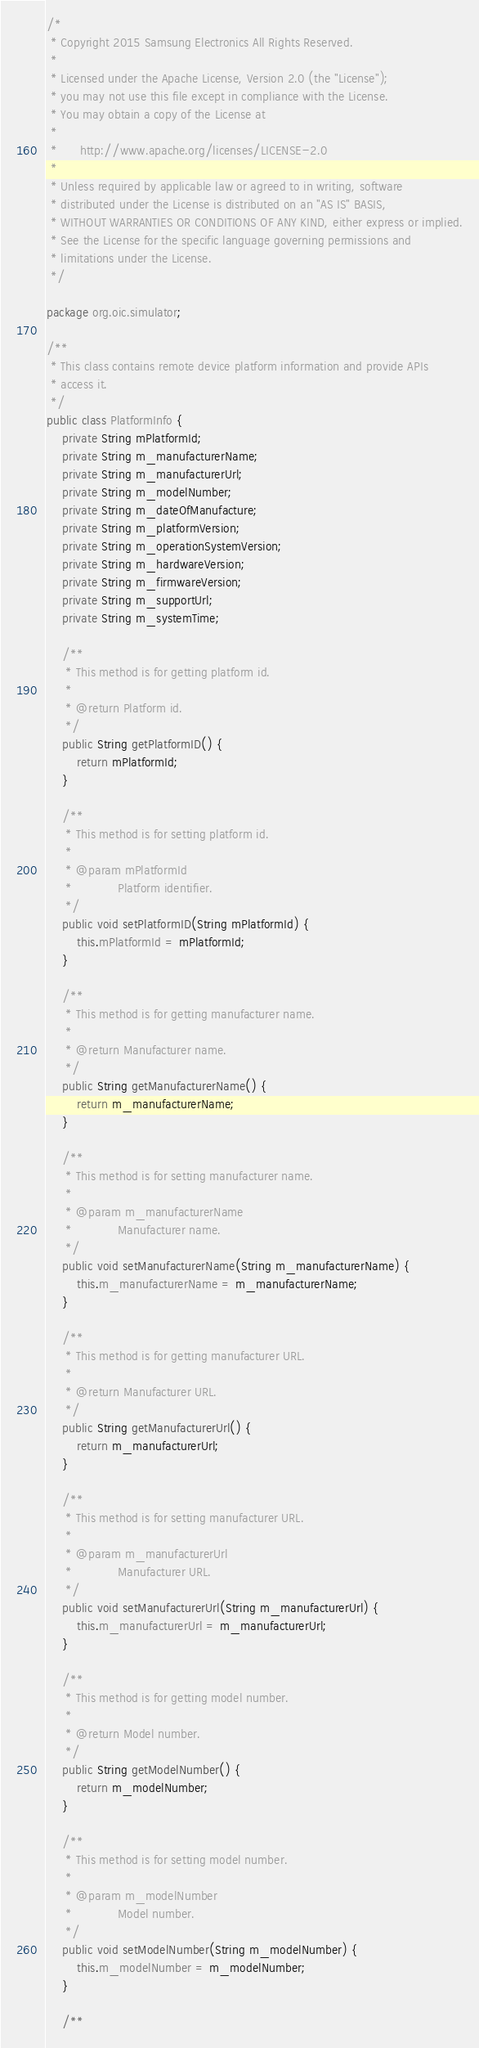Convert code to text. <code><loc_0><loc_0><loc_500><loc_500><_Java_>/*
 * Copyright 2015 Samsung Electronics All Rights Reserved.
 *
 * Licensed under the Apache License, Version 2.0 (the "License");
 * you may not use this file except in compliance with the License.
 * You may obtain a copy of the License at
 *
 *      http://www.apache.org/licenses/LICENSE-2.0
 *
 * Unless required by applicable law or agreed to in writing, software
 * distributed under the License is distributed on an "AS IS" BASIS,
 * WITHOUT WARRANTIES OR CONDITIONS OF ANY KIND, either express or implied.
 * See the License for the specific language governing permissions and
 * limitations under the License.
 */

package org.oic.simulator;

/**
 * This class contains remote device platform information and provide APIs
 * access it.
 */
public class PlatformInfo {
    private String mPlatformId;
    private String m_manufacturerName;
    private String m_manufacturerUrl;
    private String m_modelNumber;
    private String m_dateOfManufacture;
    private String m_platformVersion;
    private String m_operationSystemVersion;
    private String m_hardwareVersion;
    private String m_firmwareVersion;
    private String m_supportUrl;
    private String m_systemTime;

    /**
     * This method is for getting platform id.
     *
     * @return Platform id.
     */
    public String getPlatformID() {
        return mPlatformId;
    }

    /**
     * This method is for setting platform id.
     *
     * @param mPlatformId
     *            Platform identifier.
     */
    public void setPlatformID(String mPlatformId) {
        this.mPlatformId = mPlatformId;
    }

    /**
     * This method is for getting manufacturer name.
     *
     * @return Manufacturer name.
     */
    public String getManufacturerName() {
        return m_manufacturerName;
    }

    /**
     * This method is for setting manufacturer name.
     *
     * @param m_manufacturerName
     *            Manufacturer name.
     */
    public void setManufacturerName(String m_manufacturerName) {
        this.m_manufacturerName = m_manufacturerName;
    }

    /**
     * This method is for getting manufacturer URL.
     *
     * @return Manufacturer URL.
     */
    public String getManufacturerUrl() {
        return m_manufacturerUrl;
    }

    /**
     * This method is for setting manufacturer URL.
     *
     * @param m_manufacturerUrl
     *            Manufacturer URL.
     */
    public void setManufacturerUrl(String m_manufacturerUrl) {
        this.m_manufacturerUrl = m_manufacturerUrl;
    }

    /**
     * This method is for getting model number.
     *
     * @return Model number.
     */
    public String getModelNumber() {
        return m_modelNumber;
    }

    /**
     * This method is for setting model number.
     *
     * @param m_modelNumber
     *            Model number.
     */
    public void setModelNumber(String m_modelNumber) {
        this.m_modelNumber = m_modelNumber;
    }

    /**</code> 